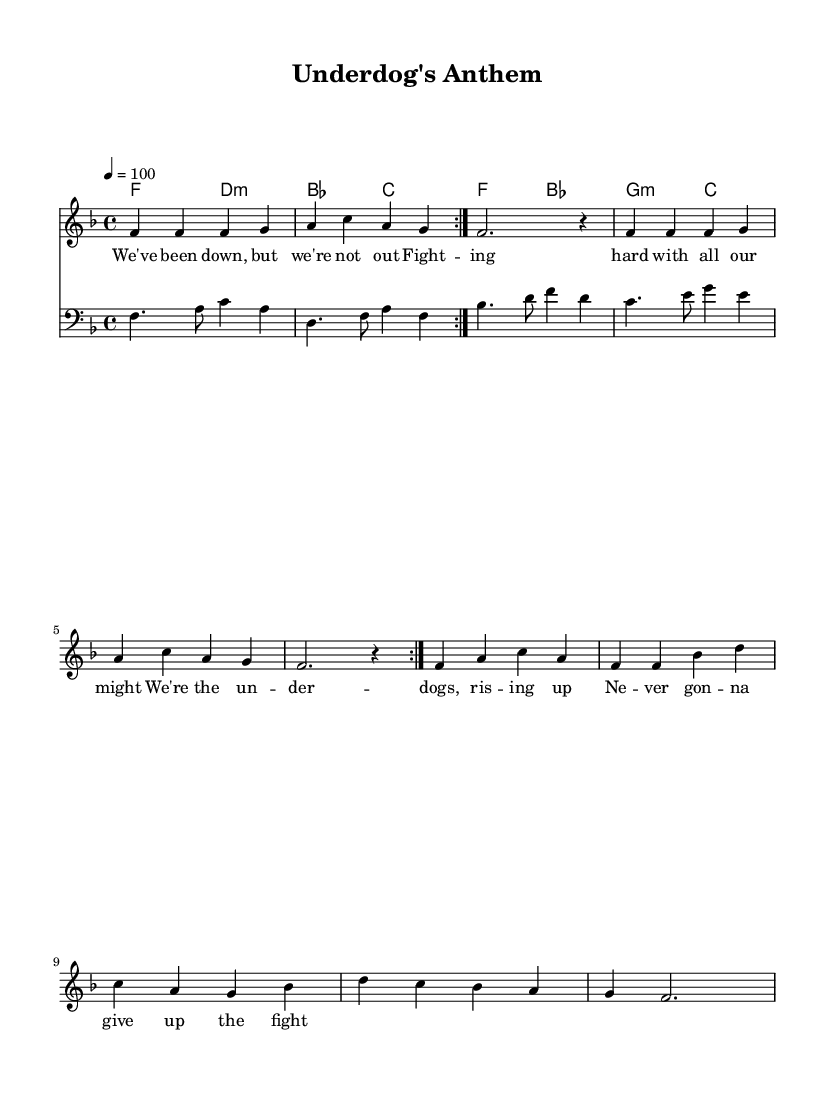What is the key signature of this music? The key signature indicates F major, which consists of one flat (B flat). This is determined by looking at the key signature placed at the beginning of the staff, which has the symbol for B flat.
Answer: F major What is the time signature of this music? The time signature shows that this piece is in 4/4 time, meaning there are four beats in each measure and the quarter note gets the beat. This is visible at the beginning of the score next to the key signature.
Answer: 4/4 What is the tempo marking for this music? The tempo is set at 100 beats per minute, indicated by the marking next to the word "tempo" in the score. This number helps to define the speed at which the music should be played.
Answer: 100 How many times is the melody repeated? The melody is repeated twice, as indicated by the "volta" markings, which signal to repeat the section of music that precedes it. This is shown through the notation that specifies repetition.
Answer: 2 What is the chord progression in the verses? The chord progression is F to D minor, B flat to C. This can be determined by following the chord names written above the staff, indicating the chords to be played.
Answer: F to D minor, B flat to C Which instrument plays the bass part? The bass part is played by the bass staff, which is indicated by the clef symbol at the beginning. This clef shows that it is intended for lower-pitched instruments like a bass guitar or double bass.
Answer: Bass What style of music does this composition reflect? The composition reflects the soul genre, which is evident through stylistic elements typical of soul music, such as the song's theme of perseverance and struggle, often represented in the lyrics and melody structure.
Answer: Soul 